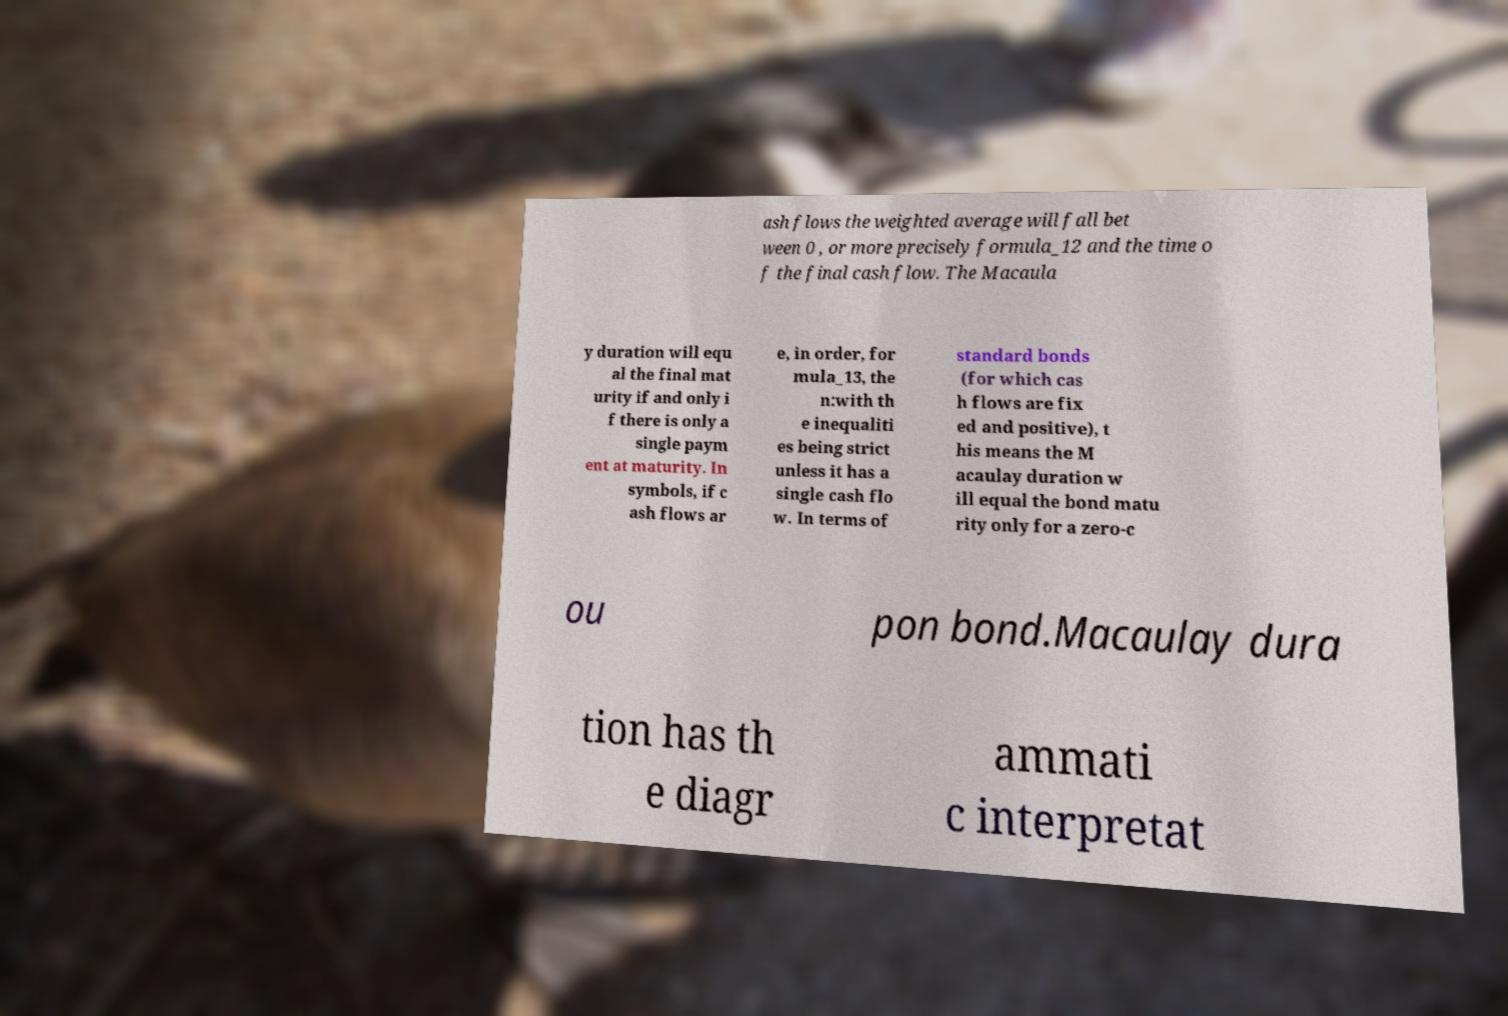Please identify and transcribe the text found in this image. ash flows the weighted average will fall bet ween 0 , or more precisely formula_12 and the time o f the final cash flow. The Macaula y duration will equ al the final mat urity if and only i f there is only a single paym ent at maturity. In symbols, if c ash flows ar e, in order, for mula_13, the n:with th e inequaliti es being strict unless it has a single cash flo w. In terms of standard bonds (for which cas h flows are fix ed and positive), t his means the M acaulay duration w ill equal the bond matu rity only for a zero-c ou pon bond.Macaulay dura tion has th e diagr ammati c interpretat 